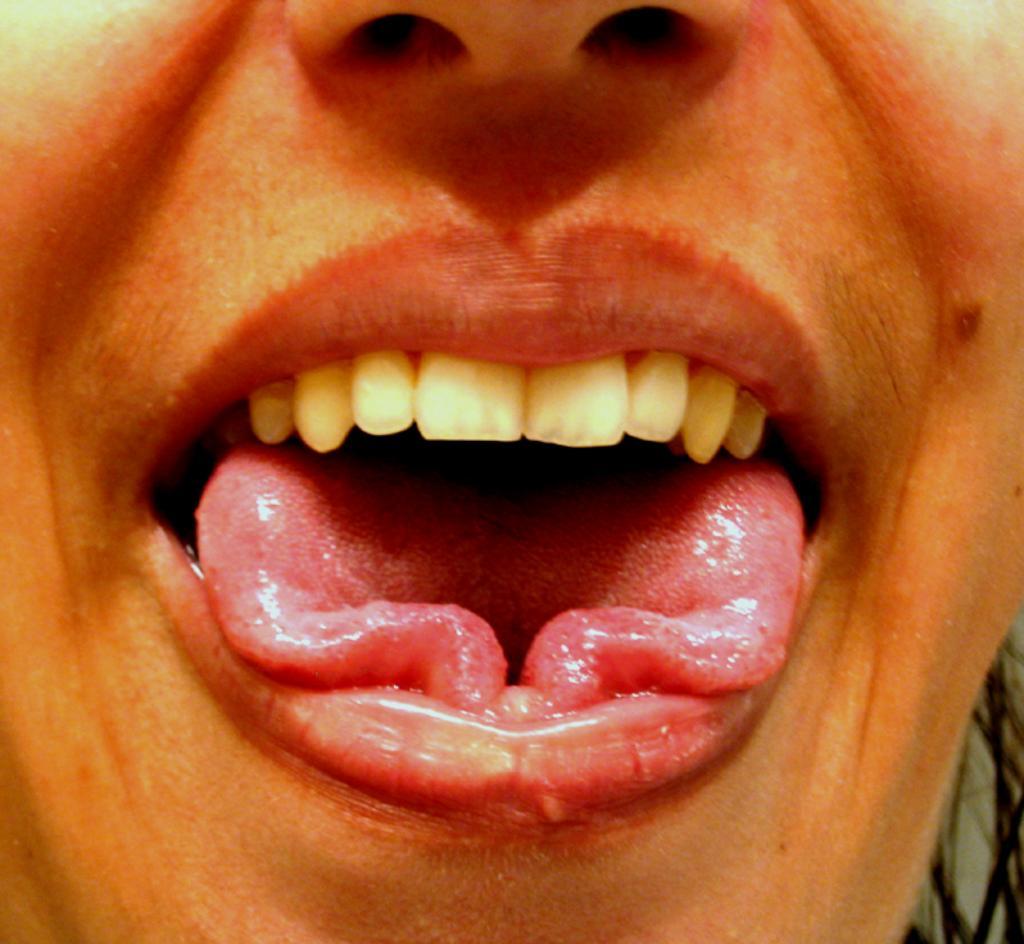Describe this image in one or two sentences. In this picture I can observe mouth of a human. There is tongue and upper teeth. I can observe nose on the top of the picture. 